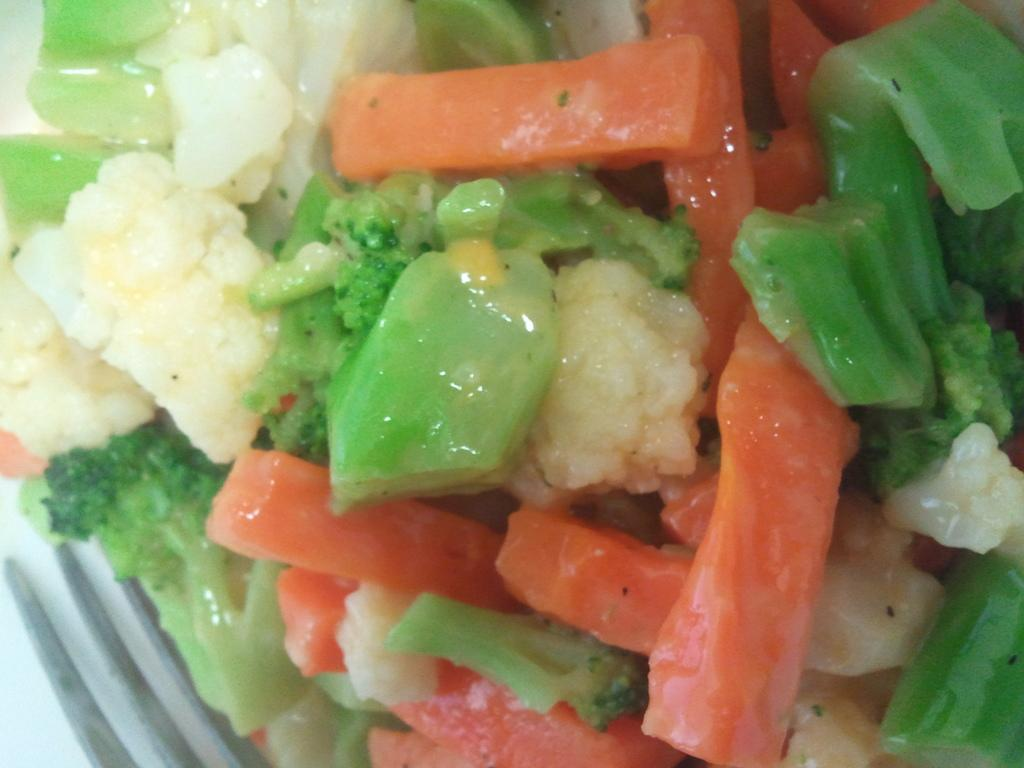What type of food can be seen in the image? There are cut pieces of vegetables in the image. Can you describe the variety of vegetables in the image? The vegetables are of different types. What type of gun is being sold in the store in the image? There is no gun or store present in the image; it only features cut pieces of vegetables. 